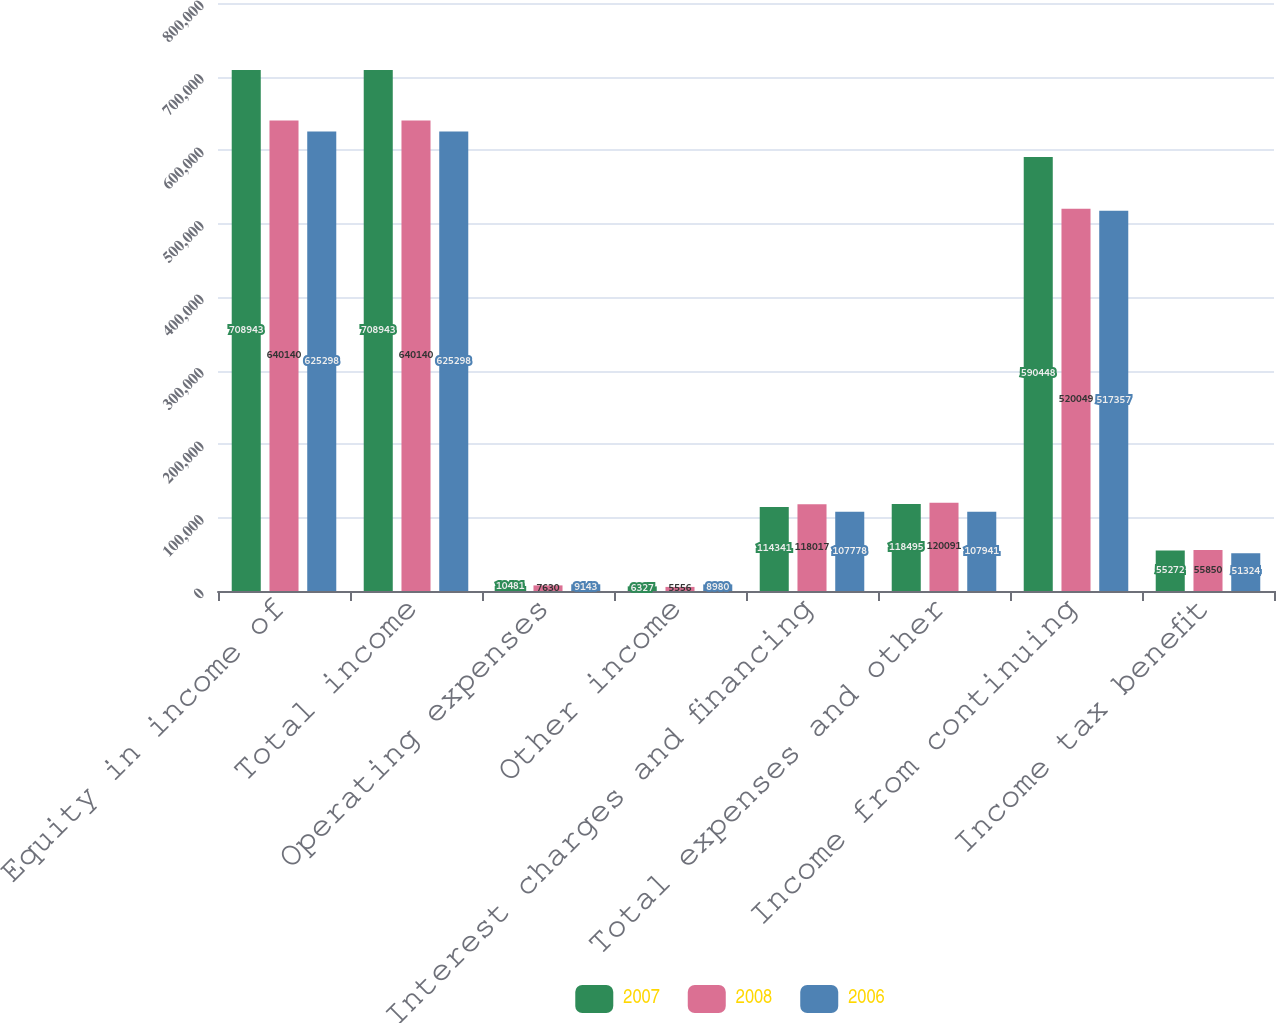Convert chart. <chart><loc_0><loc_0><loc_500><loc_500><stacked_bar_chart><ecel><fcel>Equity in income of<fcel>Total income<fcel>Operating expenses<fcel>Other income<fcel>Interest charges and financing<fcel>Total expenses and other<fcel>Income from continuing<fcel>Income tax benefit<nl><fcel>2007<fcel>708943<fcel>708943<fcel>10481<fcel>6327<fcel>114341<fcel>118495<fcel>590448<fcel>55272<nl><fcel>2008<fcel>640140<fcel>640140<fcel>7630<fcel>5556<fcel>118017<fcel>120091<fcel>520049<fcel>55850<nl><fcel>2006<fcel>625298<fcel>625298<fcel>9143<fcel>8980<fcel>107778<fcel>107941<fcel>517357<fcel>51324<nl></chart> 